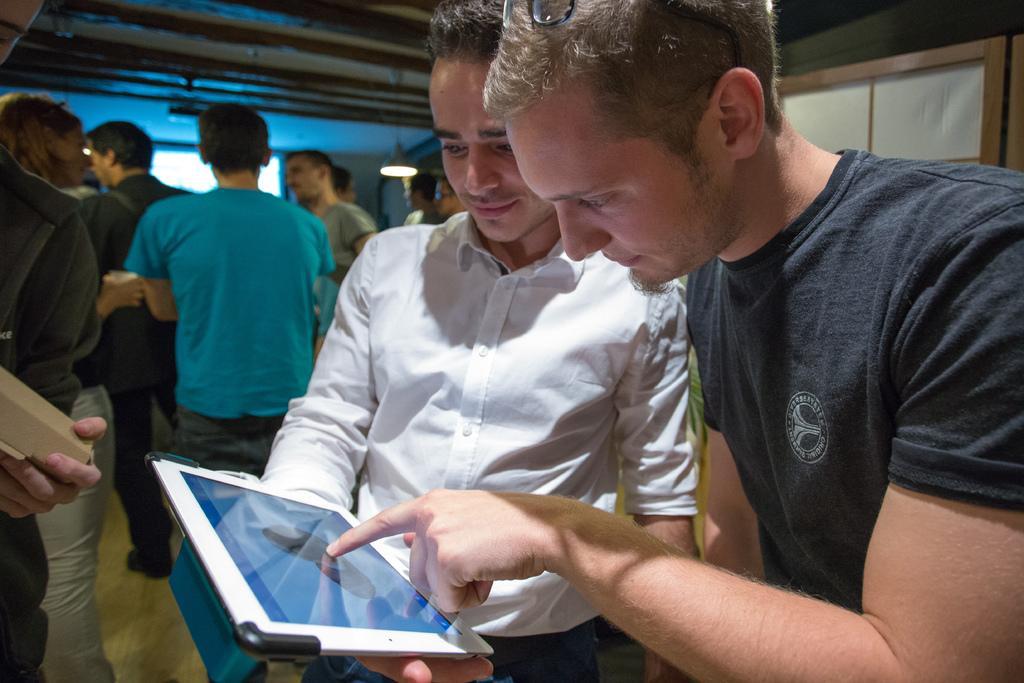Please provide a concise description of this image. In this image I can see a person wearing black colored dress and a person wearing white colored shirt are standing and I can see a person is holding an electronic gadget in his hands. In the background I can see few persons standing, the ceiling, a light hanged to the ceiling and a cream and brown colored object. 